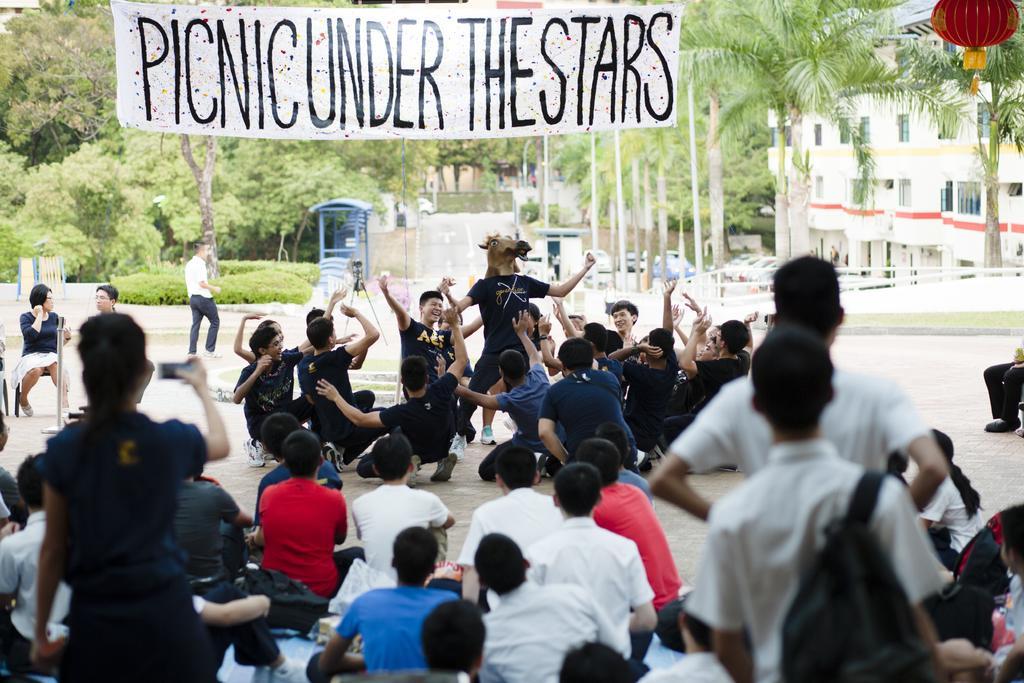Can you describe this image briefly? In this image, we can see some persons wearing clothes. There are some other persons in the middle of the image acting in a play. There is a banner at the top of the image. There is a building in the top right of the image. In the background of the image, there are some trees. 